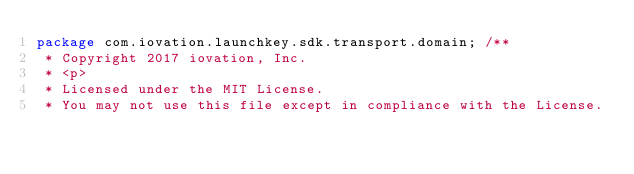Convert code to text. <code><loc_0><loc_0><loc_500><loc_500><_Java_>package com.iovation.launchkey.sdk.transport.domain; /**
 * Copyright 2017 iovation, Inc.
 * <p>
 * Licensed under the MIT License.
 * You may not use this file except in compliance with the License.</code> 